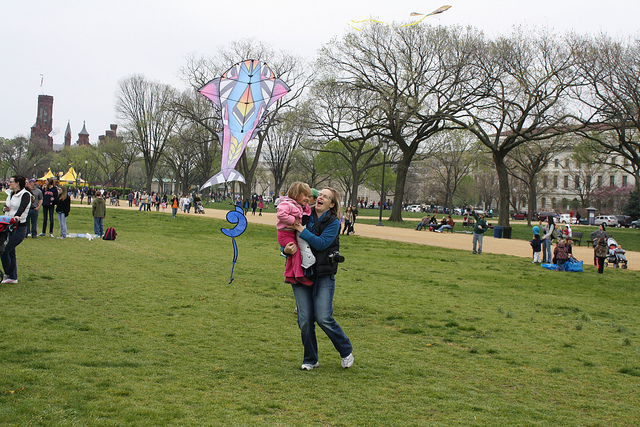<image>What game are the children playing? I am not sure what game the children are playing. It could be flying a kite or playing frisbee. What game is the woman playing? I am not sure what game the woman is playing. It could be kite flying or frisbee. What is the girl about to do? It's ambiguous what the girl is about to do, she could either run or fly a kite. What game are the children playing? It cannot be determined what game the children are playing. What game is the woman playing? I don't know what game the woman is playing. It can be either kite flying or frisbee. What is the girl about to do? I am not sure what the girl is about to do. It can be seen that she is about to fly a kite. 